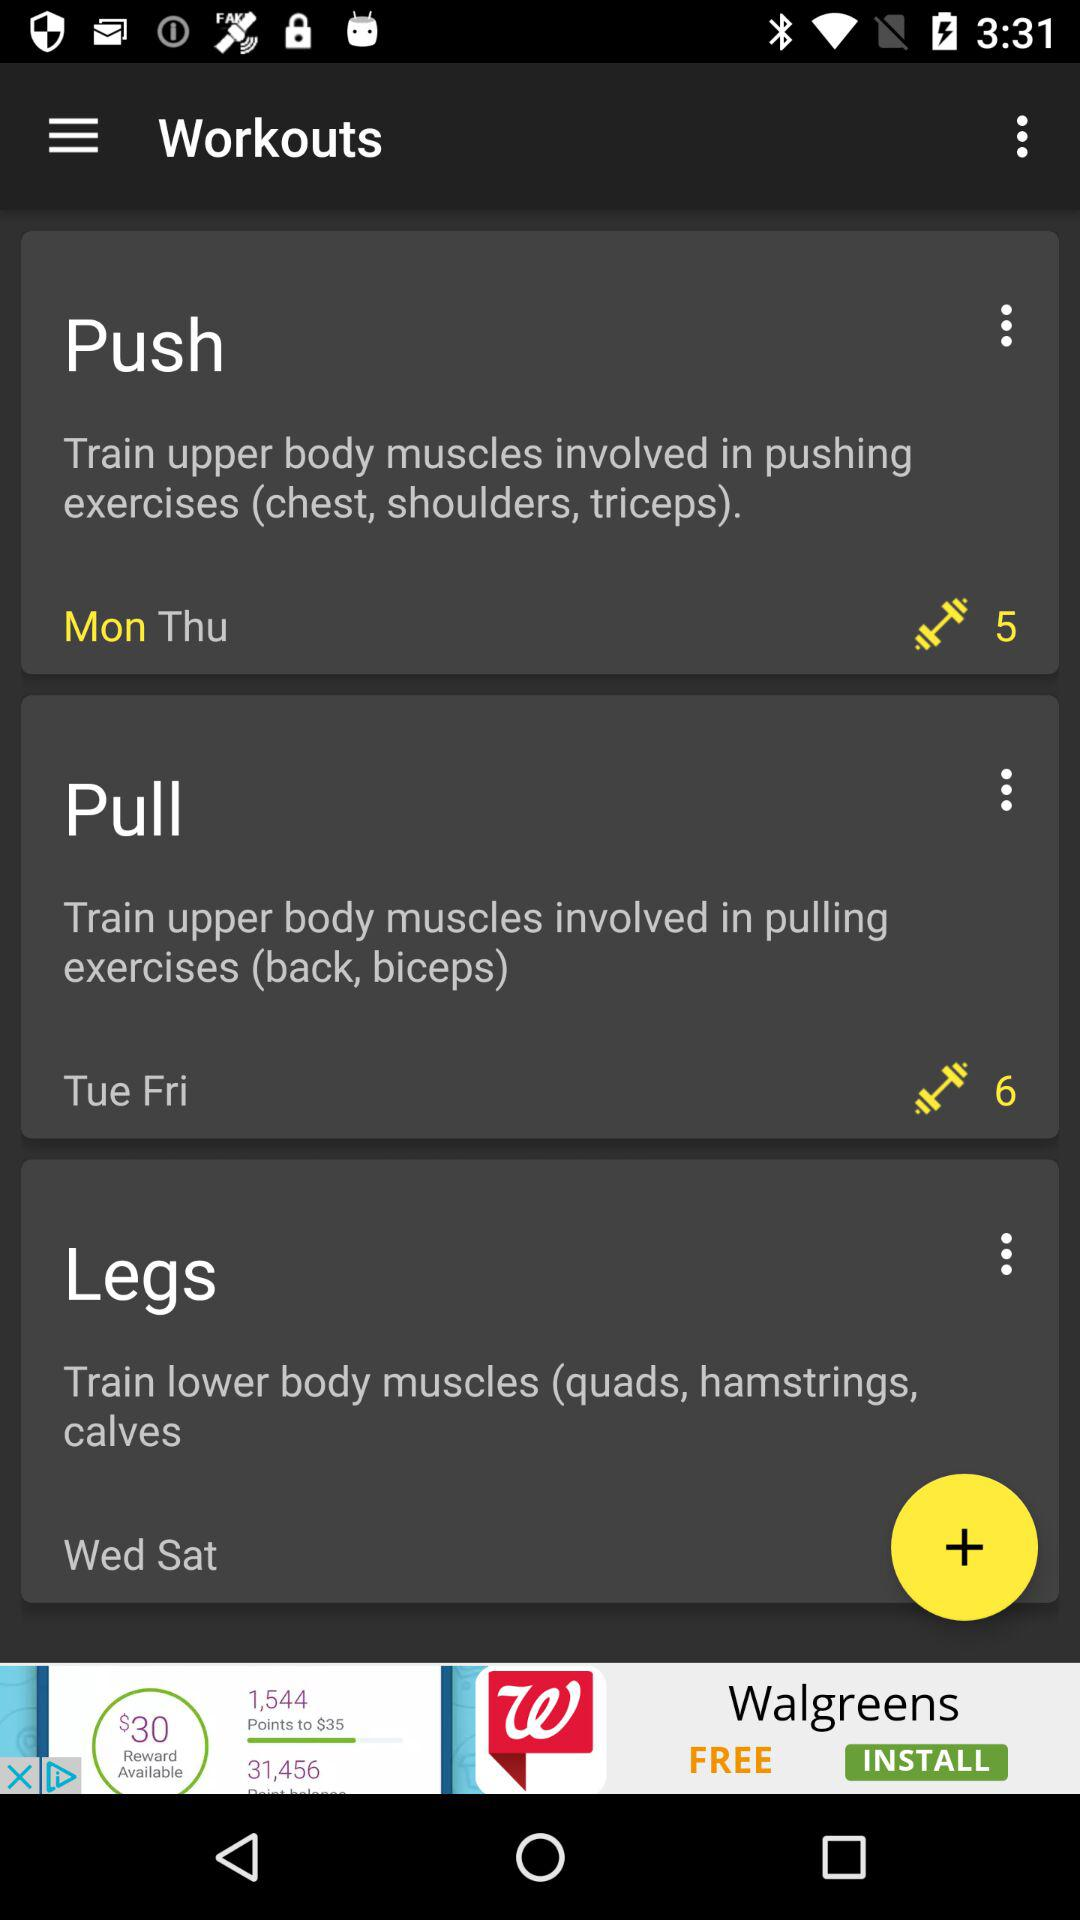Which days are for back and biceps workouts? The days for back and biceps workouts are Tuesday and Friday. 